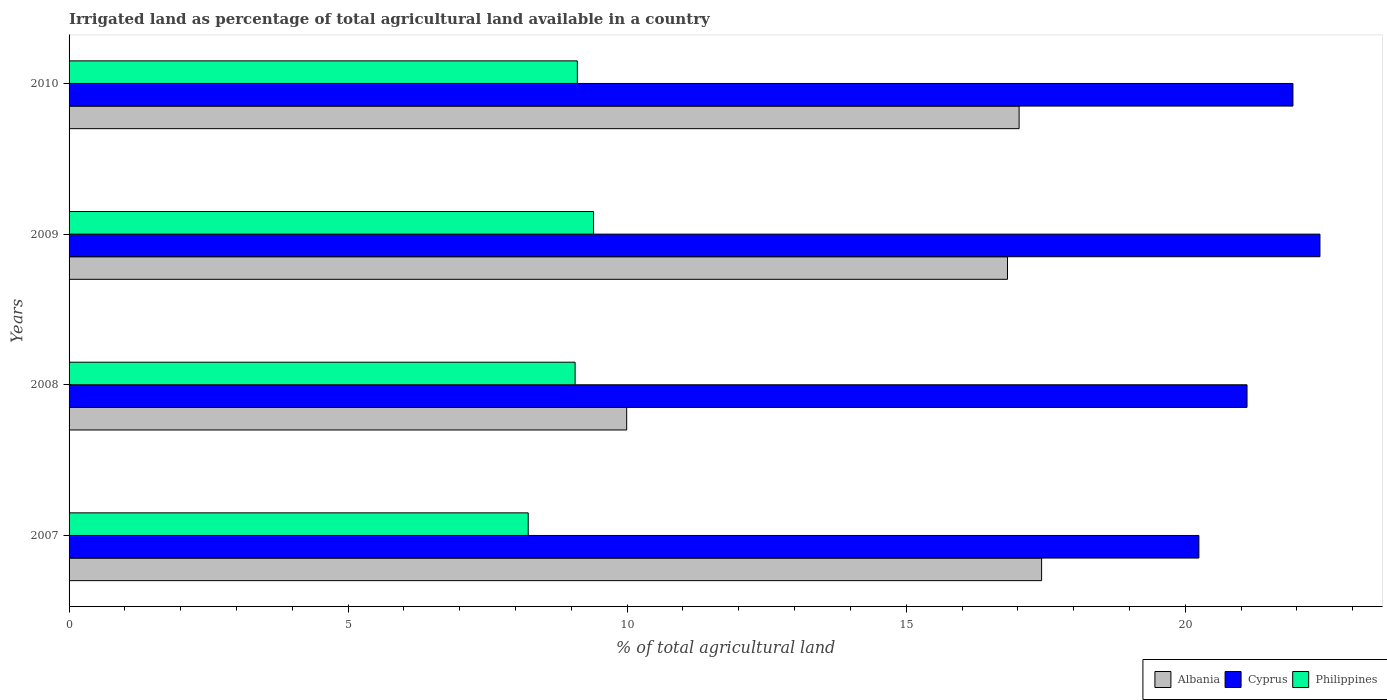How many different coloured bars are there?
Provide a succinct answer. 3. How many groups of bars are there?
Provide a short and direct response. 4. Are the number of bars on each tick of the Y-axis equal?
Provide a succinct answer. Yes. How many bars are there on the 2nd tick from the bottom?
Keep it short and to the point. 3. In how many cases, is the number of bars for a given year not equal to the number of legend labels?
Your response must be concise. 0. What is the percentage of irrigated land in Albania in 2008?
Offer a very short reply. 9.99. Across all years, what is the maximum percentage of irrigated land in Albania?
Offer a terse response. 17.43. Across all years, what is the minimum percentage of irrigated land in Philippines?
Ensure brevity in your answer.  8.23. In which year was the percentage of irrigated land in Philippines maximum?
Provide a short and direct response. 2009. What is the total percentage of irrigated land in Philippines in the graph?
Your response must be concise. 35.8. What is the difference between the percentage of irrigated land in Cyprus in 2007 and that in 2010?
Keep it short and to the point. -1.69. What is the difference between the percentage of irrigated land in Philippines in 2008 and the percentage of irrigated land in Albania in 2007?
Keep it short and to the point. -8.36. What is the average percentage of irrigated land in Albania per year?
Your response must be concise. 15.31. In the year 2008, what is the difference between the percentage of irrigated land in Cyprus and percentage of irrigated land in Albania?
Give a very brief answer. 11.12. In how many years, is the percentage of irrigated land in Cyprus greater than 11 %?
Offer a terse response. 4. What is the ratio of the percentage of irrigated land in Philippines in 2007 to that in 2008?
Keep it short and to the point. 0.91. Is the percentage of irrigated land in Cyprus in 2009 less than that in 2010?
Keep it short and to the point. No. Is the difference between the percentage of irrigated land in Cyprus in 2007 and 2010 greater than the difference between the percentage of irrigated land in Albania in 2007 and 2010?
Your response must be concise. No. What is the difference between the highest and the second highest percentage of irrigated land in Philippines?
Ensure brevity in your answer.  0.29. What is the difference between the highest and the lowest percentage of irrigated land in Philippines?
Your response must be concise. 1.17. What does the 3rd bar from the top in 2007 represents?
Your answer should be very brief. Albania. What does the 2nd bar from the bottom in 2007 represents?
Provide a succinct answer. Cyprus. How many bars are there?
Offer a terse response. 12. Are all the bars in the graph horizontal?
Your answer should be very brief. Yes. What is the difference between two consecutive major ticks on the X-axis?
Ensure brevity in your answer.  5. Does the graph contain grids?
Give a very brief answer. No. Where does the legend appear in the graph?
Your answer should be compact. Bottom right. How many legend labels are there?
Keep it short and to the point. 3. How are the legend labels stacked?
Offer a very short reply. Horizontal. What is the title of the graph?
Your answer should be compact. Irrigated land as percentage of total agricultural land available in a country. Does "Austria" appear as one of the legend labels in the graph?
Provide a short and direct response. No. What is the label or title of the X-axis?
Provide a succinct answer. % of total agricultural land. What is the % of total agricultural land in Albania in 2007?
Your answer should be compact. 17.43. What is the % of total agricultural land in Cyprus in 2007?
Provide a succinct answer. 20.24. What is the % of total agricultural land in Philippines in 2007?
Offer a very short reply. 8.23. What is the % of total agricultural land in Albania in 2008?
Give a very brief answer. 9.99. What is the % of total agricultural land in Cyprus in 2008?
Your answer should be very brief. 21.11. What is the % of total agricultural land of Philippines in 2008?
Ensure brevity in your answer.  9.07. What is the % of total agricultural land in Albania in 2009?
Make the answer very short. 16.82. What is the % of total agricultural land of Cyprus in 2009?
Your answer should be very brief. 22.41. What is the % of total agricultural land of Philippines in 2009?
Ensure brevity in your answer.  9.4. What is the % of total agricultural land of Albania in 2010?
Your answer should be very brief. 17.02. What is the % of total agricultural land of Cyprus in 2010?
Your response must be concise. 21.93. What is the % of total agricultural land in Philippines in 2010?
Your answer should be compact. 9.11. Across all years, what is the maximum % of total agricultural land of Albania?
Provide a succinct answer. 17.43. Across all years, what is the maximum % of total agricultural land in Cyprus?
Ensure brevity in your answer.  22.41. Across all years, what is the maximum % of total agricultural land in Philippines?
Your answer should be very brief. 9.4. Across all years, what is the minimum % of total agricultural land of Albania?
Offer a terse response. 9.99. Across all years, what is the minimum % of total agricultural land in Cyprus?
Make the answer very short. 20.24. Across all years, what is the minimum % of total agricultural land of Philippines?
Provide a short and direct response. 8.23. What is the total % of total agricultural land in Albania in the graph?
Offer a very short reply. 61.26. What is the total % of total agricultural land of Cyprus in the graph?
Offer a very short reply. 85.7. What is the total % of total agricultural land in Philippines in the graph?
Your answer should be very brief. 35.8. What is the difference between the % of total agricultural land of Albania in 2007 and that in 2008?
Your answer should be compact. 7.43. What is the difference between the % of total agricultural land in Cyprus in 2007 and that in 2008?
Provide a short and direct response. -0.86. What is the difference between the % of total agricultural land of Philippines in 2007 and that in 2008?
Your response must be concise. -0.84. What is the difference between the % of total agricultural land in Albania in 2007 and that in 2009?
Your response must be concise. 0.61. What is the difference between the % of total agricultural land of Cyprus in 2007 and that in 2009?
Make the answer very short. -2.17. What is the difference between the % of total agricultural land of Philippines in 2007 and that in 2009?
Provide a succinct answer. -1.17. What is the difference between the % of total agricultural land in Albania in 2007 and that in 2010?
Your response must be concise. 0.4. What is the difference between the % of total agricultural land of Cyprus in 2007 and that in 2010?
Your response must be concise. -1.69. What is the difference between the % of total agricultural land in Philippines in 2007 and that in 2010?
Make the answer very short. -0.88. What is the difference between the % of total agricultural land of Albania in 2008 and that in 2009?
Offer a terse response. -6.82. What is the difference between the % of total agricultural land in Cyprus in 2008 and that in 2009?
Your answer should be very brief. -1.31. What is the difference between the % of total agricultural land in Philippines in 2008 and that in 2009?
Provide a succinct answer. -0.33. What is the difference between the % of total agricultural land in Albania in 2008 and that in 2010?
Give a very brief answer. -7.03. What is the difference between the % of total agricultural land of Cyprus in 2008 and that in 2010?
Keep it short and to the point. -0.82. What is the difference between the % of total agricultural land in Philippines in 2008 and that in 2010?
Provide a succinct answer. -0.04. What is the difference between the % of total agricultural land of Albania in 2009 and that in 2010?
Offer a very short reply. -0.21. What is the difference between the % of total agricultural land in Cyprus in 2009 and that in 2010?
Provide a short and direct response. 0.48. What is the difference between the % of total agricultural land in Philippines in 2009 and that in 2010?
Provide a succinct answer. 0.29. What is the difference between the % of total agricultural land of Albania in 2007 and the % of total agricultural land of Cyprus in 2008?
Ensure brevity in your answer.  -3.68. What is the difference between the % of total agricultural land of Albania in 2007 and the % of total agricultural land of Philippines in 2008?
Your answer should be compact. 8.36. What is the difference between the % of total agricultural land in Cyprus in 2007 and the % of total agricultural land in Philippines in 2008?
Provide a succinct answer. 11.18. What is the difference between the % of total agricultural land in Albania in 2007 and the % of total agricultural land in Cyprus in 2009?
Your answer should be compact. -4.99. What is the difference between the % of total agricultural land in Albania in 2007 and the % of total agricultural land in Philippines in 2009?
Make the answer very short. 8.03. What is the difference between the % of total agricultural land of Cyprus in 2007 and the % of total agricultural land of Philippines in 2009?
Your answer should be compact. 10.85. What is the difference between the % of total agricultural land in Albania in 2007 and the % of total agricultural land in Cyprus in 2010?
Make the answer very short. -4.5. What is the difference between the % of total agricultural land of Albania in 2007 and the % of total agricultural land of Philippines in 2010?
Keep it short and to the point. 8.32. What is the difference between the % of total agricultural land of Cyprus in 2007 and the % of total agricultural land of Philippines in 2010?
Give a very brief answer. 11.14. What is the difference between the % of total agricultural land of Albania in 2008 and the % of total agricultural land of Cyprus in 2009?
Provide a short and direct response. -12.42. What is the difference between the % of total agricultural land of Albania in 2008 and the % of total agricultural land of Philippines in 2009?
Your response must be concise. 0.59. What is the difference between the % of total agricultural land in Cyprus in 2008 and the % of total agricultural land in Philippines in 2009?
Keep it short and to the point. 11.71. What is the difference between the % of total agricultural land of Albania in 2008 and the % of total agricultural land of Cyprus in 2010?
Make the answer very short. -11.94. What is the difference between the % of total agricultural land in Albania in 2008 and the % of total agricultural land in Philippines in 2010?
Keep it short and to the point. 0.88. What is the difference between the % of total agricultural land of Cyprus in 2008 and the % of total agricultural land of Philippines in 2010?
Provide a succinct answer. 12. What is the difference between the % of total agricultural land in Albania in 2009 and the % of total agricultural land in Cyprus in 2010?
Keep it short and to the point. -5.11. What is the difference between the % of total agricultural land in Albania in 2009 and the % of total agricultural land in Philippines in 2010?
Provide a succinct answer. 7.71. What is the difference between the % of total agricultural land in Cyprus in 2009 and the % of total agricultural land in Philippines in 2010?
Provide a succinct answer. 13.31. What is the average % of total agricultural land in Albania per year?
Keep it short and to the point. 15.31. What is the average % of total agricultural land of Cyprus per year?
Ensure brevity in your answer.  21.42. What is the average % of total agricultural land of Philippines per year?
Offer a very short reply. 8.95. In the year 2007, what is the difference between the % of total agricultural land of Albania and % of total agricultural land of Cyprus?
Ensure brevity in your answer.  -2.82. In the year 2007, what is the difference between the % of total agricultural land in Albania and % of total agricultural land in Philippines?
Keep it short and to the point. 9.2. In the year 2007, what is the difference between the % of total agricultural land of Cyprus and % of total agricultural land of Philippines?
Ensure brevity in your answer.  12.02. In the year 2008, what is the difference between the % of total agricultural land of Albania and % of total agricultural land of Cyprus?
Your answer should be very brief. -11.12. In the year 2008, what is the difference between the % of total agricultural land of Albania and % of total agricultural land of Philippines?
Provide a short and direct response. 0.92. In the year 2008, what is the difference between the % of total agricultural land in Cyprus and % of total agricultural land in Philippines?
Your response must be concise. 12.04. In the year 2009, what is the difference between the % of total agricultural land of Albania and % of total agricultural land of Cyprus?
Offer a terse response. -5.6. In the year 2009, what is the difference between the % of total agricultural land of Albania and % of total agricultural land of Philippines?
Your answer should be very brief. 7.42. In the year 2009, what is the difference between the % of total agricultural land of Cyprus and % of total agricultural land of Philippines?
Provide a succinct answer. 13.02. In the year 2010, what is the difference between the % of total agricultural land in Albania and % of total agricultural land in Cyprus?
Offer a very short reply. -4.91. In the year 2010, what is the difference between the % of total agricultural land of Albania and % of total agricultural land of Philippines?
Offer a very short reply. 7.92. In the year 2010, what is the difference between the % of total agricultural land of Cyprus and % of total agricultural land of Philippines?
Offer a terse response. 12.82. What is the ratio of the % of total agricultural land in Albania in 2007 to that in 2008?
Ensure brevity in your answer.  1.74. What is the ratio of the % of total agricultural land in Cyprus in 2007 to that in 2008?
Keep it short and to the point. 0.96. What is the ratio of the % of total agricultural land of Philippines in 2007 to that in 2008?
Your answer should be compact. 0.91. What is the ratio of the % of total agricultural land in Albania in 2007 to that in 2009?
Keep it short and to the point. 1.04. What is the ratio of the % of total agricultural land of Cyprus in 2007 to that in 2009?
Give a very brief answer. 0.9. What is the ratio of the % of total agricultural land in Philippines in 2007 to that in 2009?
Ensure brevity in your answer.  0.88. What is the ratio of the % of total agricultural land in Albania in 2007 to that in 2010?
Your answer should be compact. 1.02. What is the ratio of the % of total agricultural land in Cyprus in 2007 to that in 2010?
Give a very brief answer. 0.92. What is the ratio of the % of total agricultural land of Philippines in 2007 to that in 2010?
Offer a terse response. 0.9. What is the ratio of the % of total agricultural land in Albania in 2008 to that in 2009?
Your answer should be compact. 0.59. What is the ratio of the % of total agricultural land in Cyprus in 2008 to that in 2009?
Make the answer very short. 0.94. What is the ratio of the % of total agricultural land of Albania in 2008 to that in 2010?
Your answer should be compact. 0.59. What is the ratio of the % of total agricultural land of Cyprus in 2008 to that in 2010?
Offer a very short reply. 0.96. What is the ratio of the % of total agricultural land in Cyprus in 2009 to that in 2010?
Offer a very short reply. 1.02. What is the ratio of the % of total agricultural land of Philippines in 2009 to that in 2010?
Provide a succinct answer. 1.03. What is the difference between the highest and the second highest % of total agricultural land of Albania?
Offer a very short reply. 0.4. What is the difference between the highest and the second highest % of total agricultural land in Cyprus?
Your answer should be compact. 0.48. What is the difference between the highest and the second highest % of total agricultural land in Philippines?
Your response must be concise. 0.29. What is the difference between the highest and the lowest % of total agricultural land in Albania?
Make the answer very short. 7.43. What is the difference between the highest and the lowest % of total agricultural land in Cyprus?
Your answer should be compact. 2.17. What is the difference between the highest and the lowest % of total agricultural land in Philippines?
Provide a short and direct response. 1.17. 